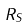Convert formula to latex. <formula><loc_0><loc_0><loc_500><loc_500>R _ { S }</formula> 